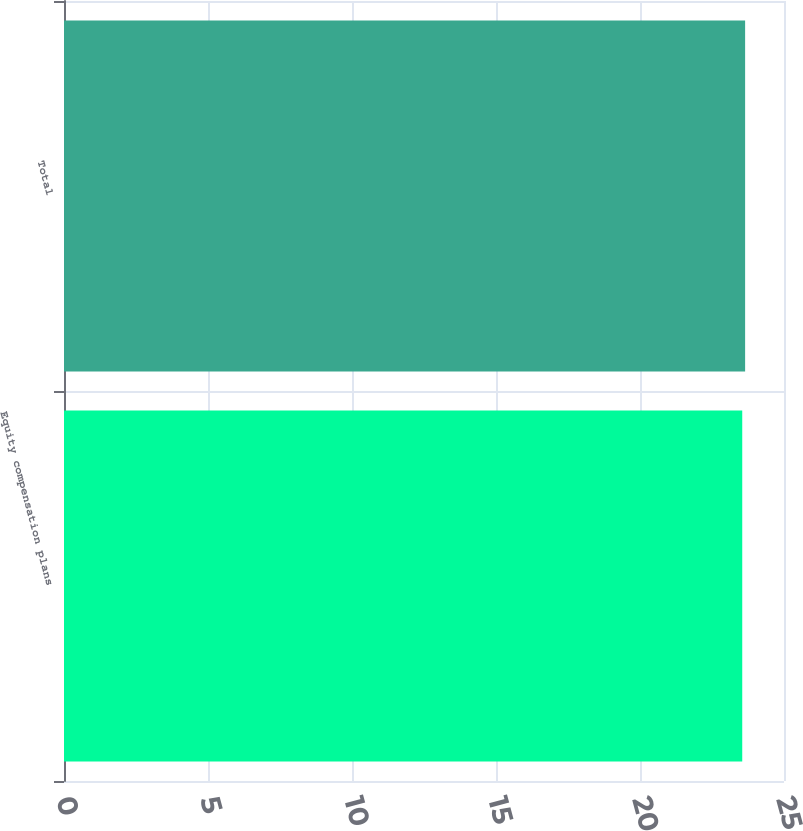Convert chart to OTSL. <chart><loc_0><loc_0><loc_500><loc_500><bar_chart><fcel>Equity compensation plans<fcel>Total<nl><fcel>23.55<fcel>23.65<nl></chart> 